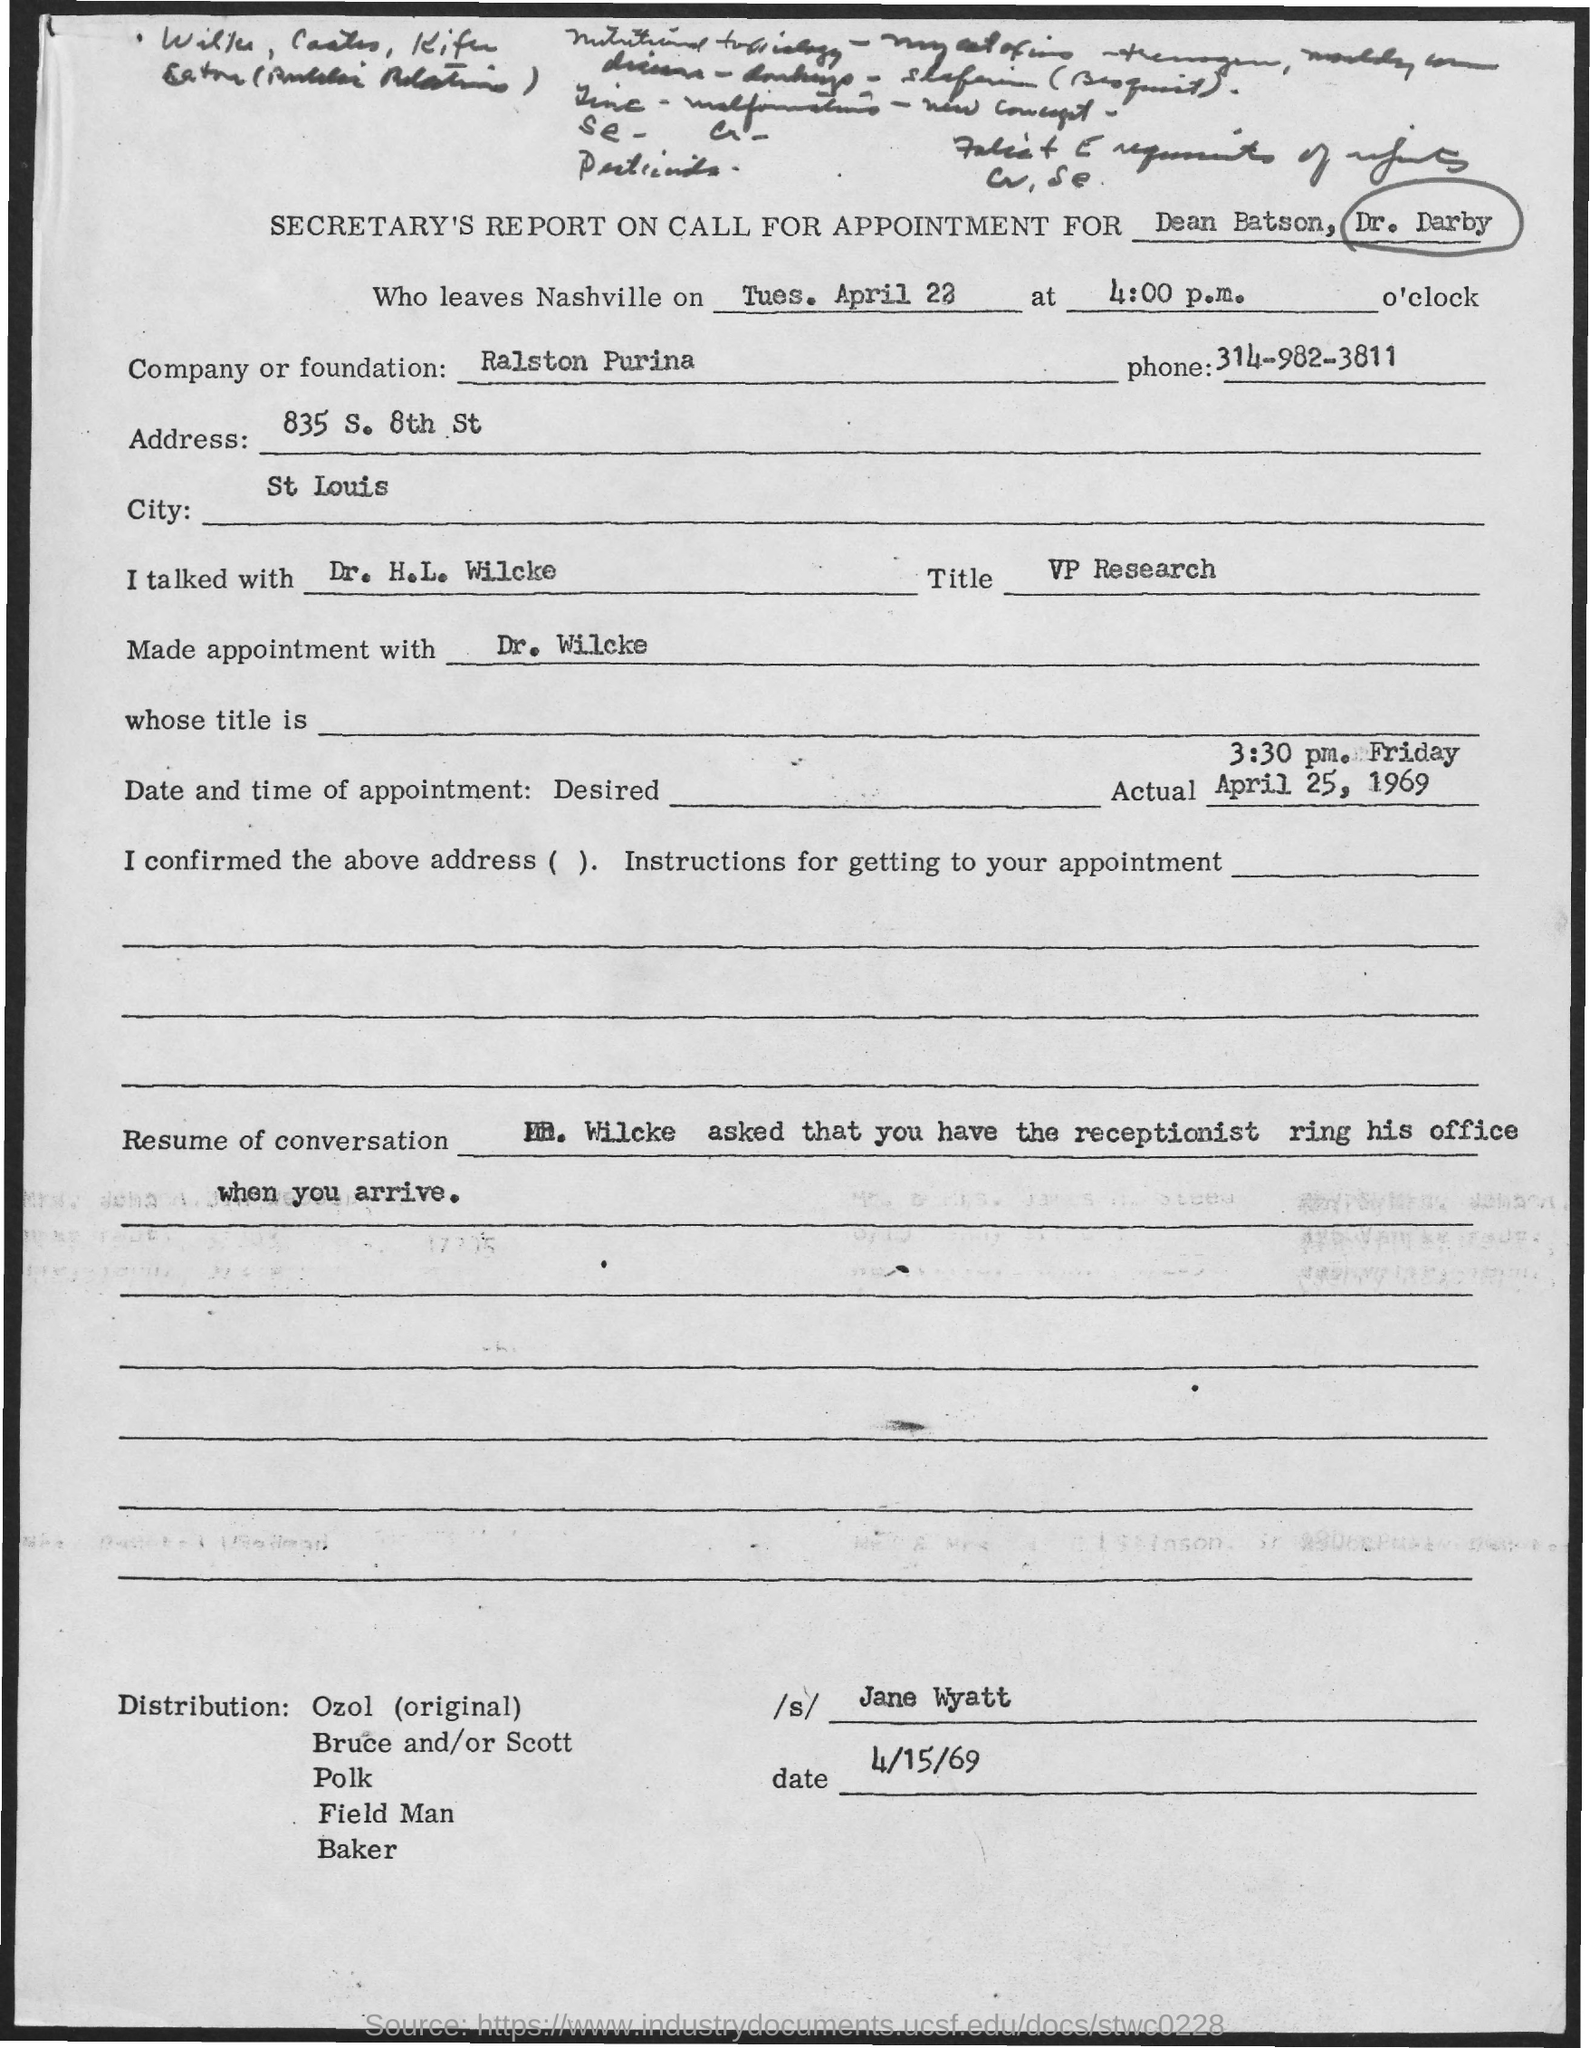Outline some significant characteristics in this image. The company or foundation named in the document is Ralston Purina. The phone number of Ralston Purina is 314-982-3811. The signed document is signed by Jane Wyatt. Dr. H.L. Wilcke's job title is Vice President of Research. 